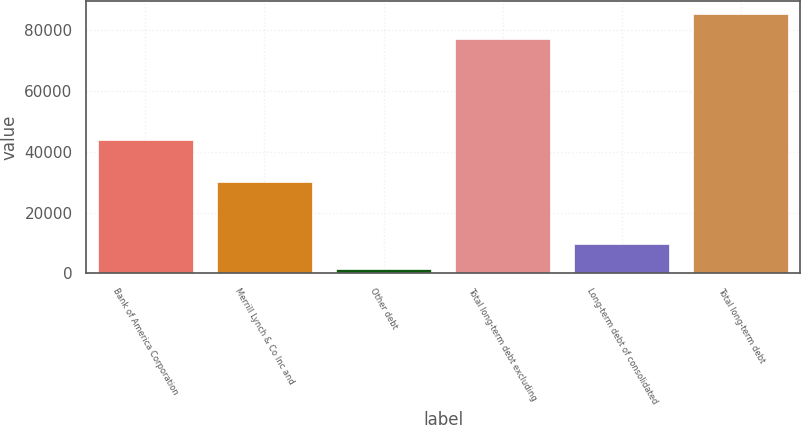Convert chart to OTSL. <chart><loc_0><loc_0><loc_500><loc_500><bar_chart><fcel>Bank of America Corporation<fcel>Merrill Lynch & Co Inc and<fcel>Other debt<fcel>Total long-term debt excluding<fcel>Long-term debt of consolidated<fcel>Total long-term debt<nl><fcel>43806<fcel>29975<fcel>1488<fcel>77134<fcel>9686.2<fcel>85332.2<nl></chart> 